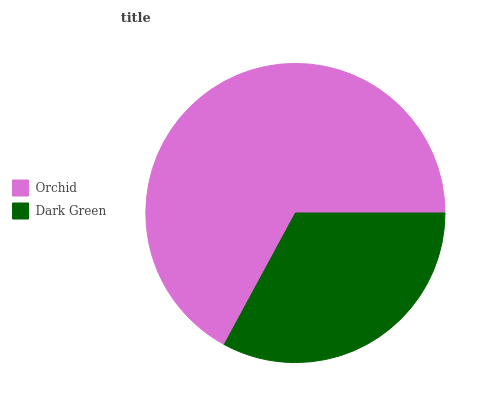Is Dark Green the minimum?
Answer yes or no. Yes. Is Orchid the maximum?
Answer yes or no. Yes. Is Dark Green the maximum?
Answer yes or no. No. Is Orchid greater than Dark Green?
Answer yes or no. Yes. Is Dark Green less than Orchid?
Answer yes or no. Yes. Is Dark Green greater than Orchid?
Answer yes or no. No. Is Orchid less than Dark Green?
Answer yes or no. No. Is Orchid the high median?
Answer yes or no. Yes. Is Dark Green the low median?
Answer yes or no. Yes. Is Dark Green the high median?
Answer yes or no. No. Is Orchid the low median?
Answer yes or no. No. 